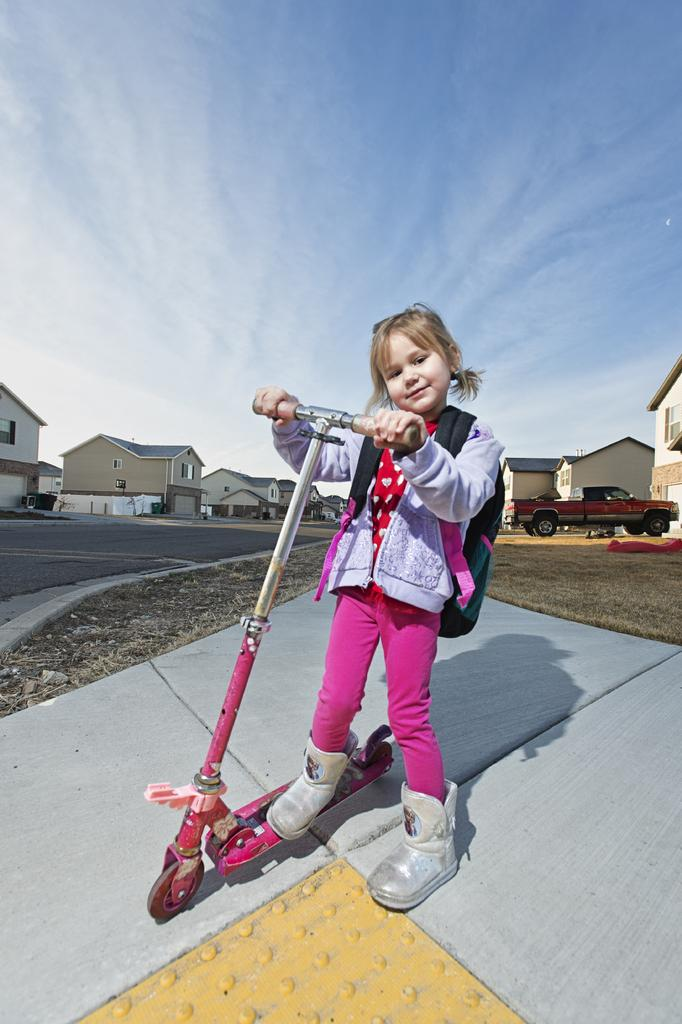What is the main subject of the image? The main subject of the image is a kid. What is the kid carrying on her back? The kid is carrying a bag on her back. What is the kid riding in the image? The kid is on a skate cycle. What can be seen in the background of the image? There are vehicles and buildings in the background of the image. What type of stomach pain is the kid experiencing in the image? There is no indication of stomach pain in the image; the kid is riding a skate cycle and carrying a bag. How is the giraffe helping the kid in the image? There is no giraffe present in the image, so it cannot help the kid. 